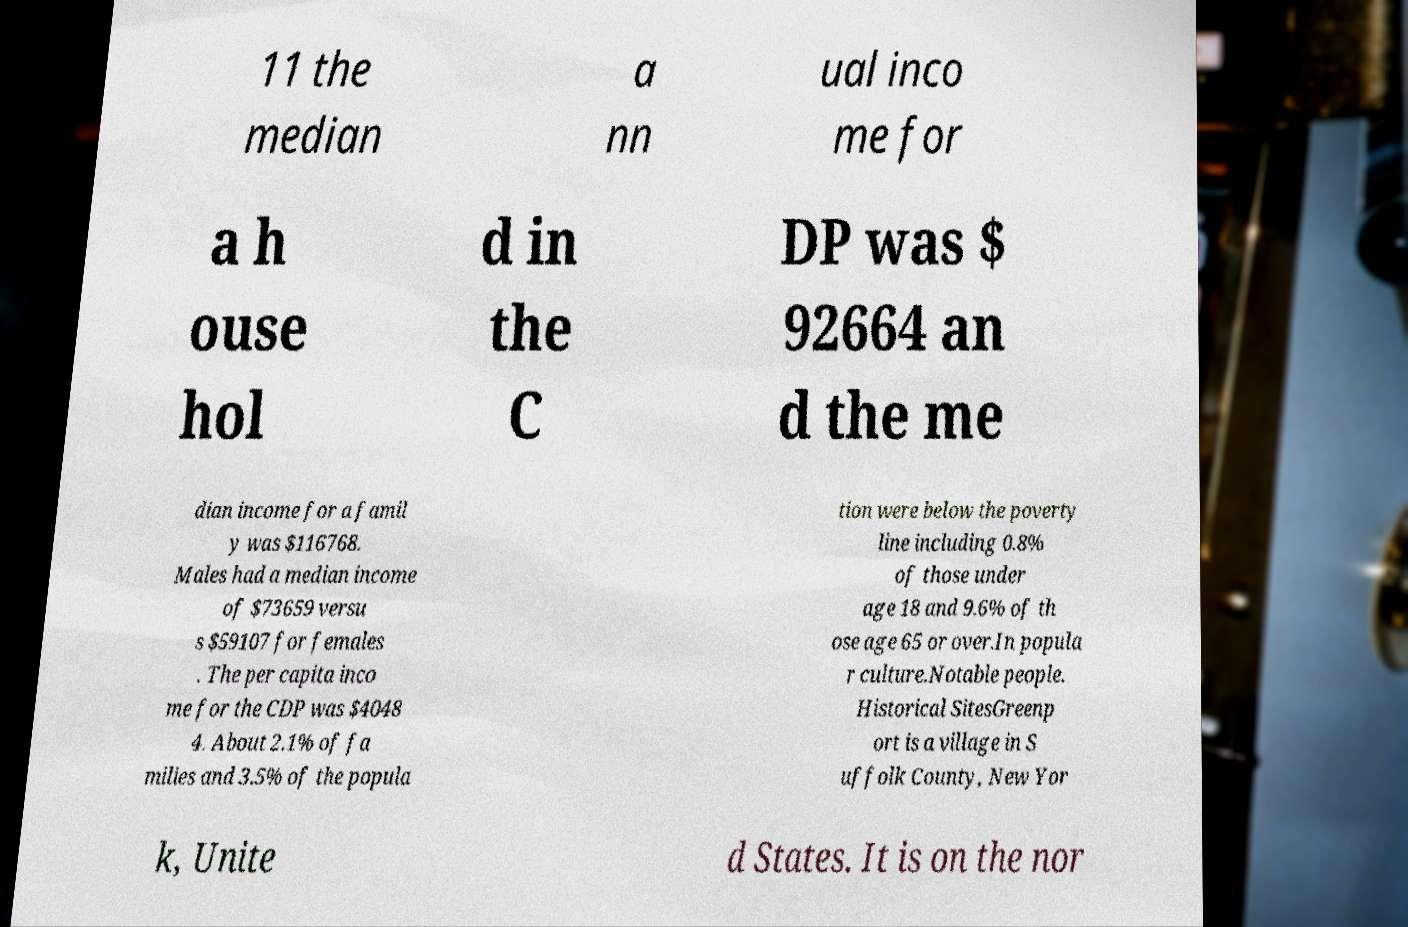Could you extract and type out the text from this image? 11 the median a nn ual inco me for a h ouse hol d in the C DP was $ 92664 an d the me dian income for a famil y was $116768. Males had a median income of $73659 versu s $59107 for females . The per capita inco me for the CDP was $4048 4. About 2.1% of fa milies and 3.5% of the popula tion were below the poverty line including 0.8% of those under age 18 and 9.6% of th ose age 65 or over.In popula r culture.Notable people. Historical SitesGreenp ort is a village in S uffolk County, New Yor k, Unite d States. It is on the nor 